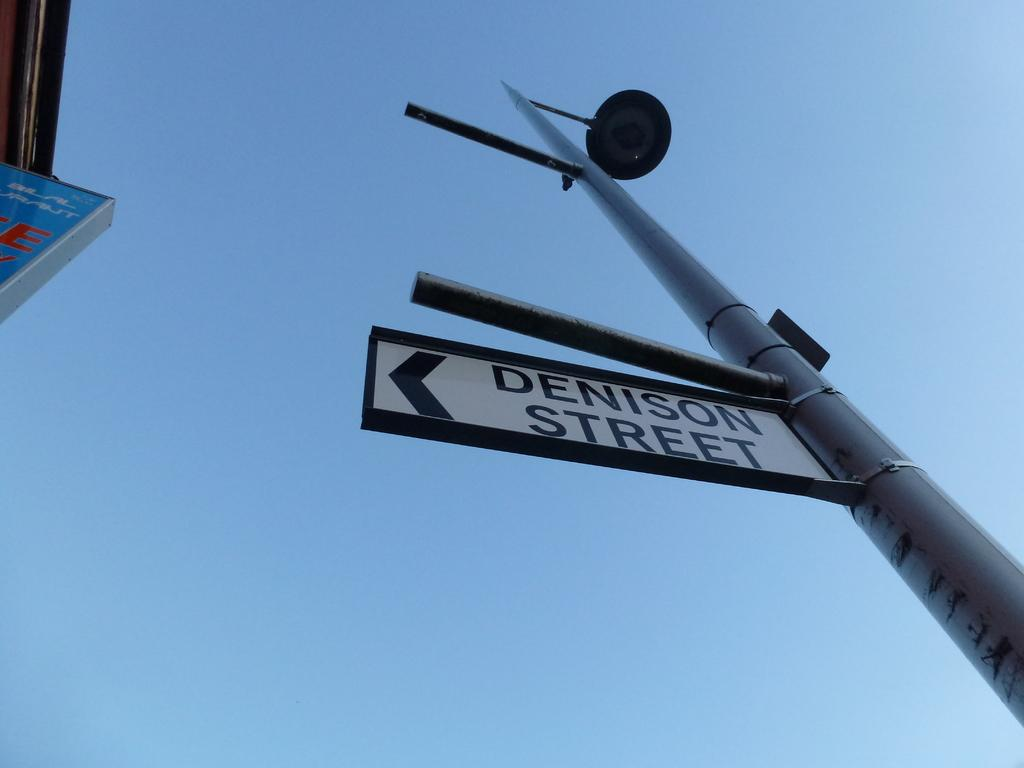<image>
Write a terse but informative summary of the picture. A street sign post with a sign attached to the post that says Denison Street, 